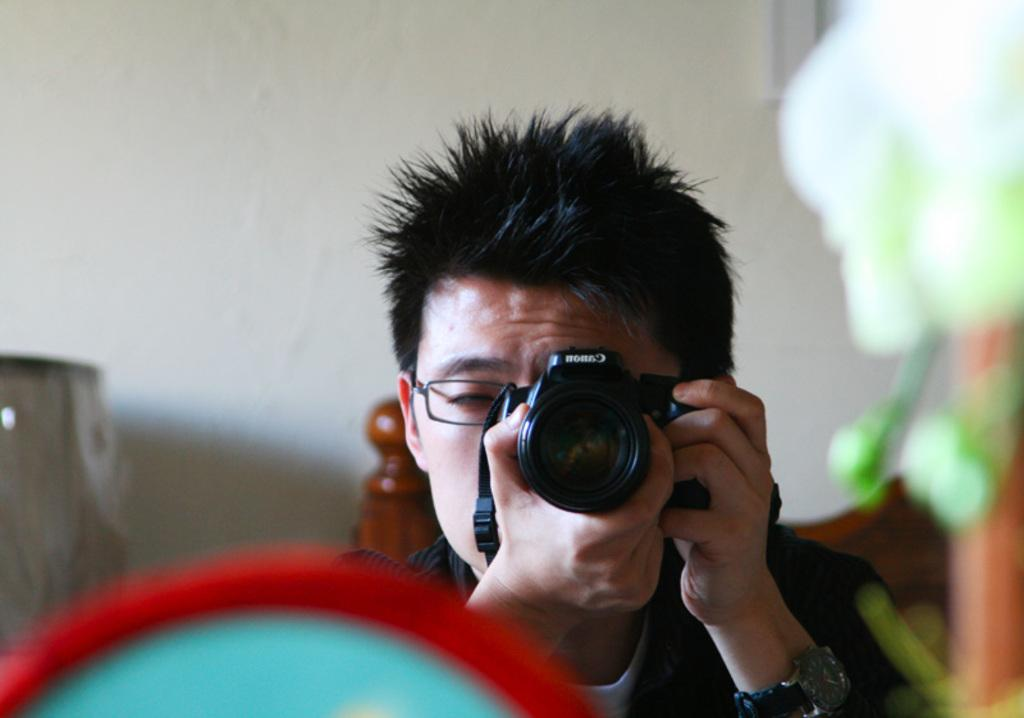Who is the main subject in the image? There is a man in the image. What is the man doing in the image? The man is holding a camera near his eye. What brand of camera is the man using? The camera has "Canon" written on it. What accessories is the man wearing in the image? The man is wearing glasses (specs) and a watch. What color is the man's dress in the image? The man is wearing a black color dress. What channel is the man watching in the image? There is no mention of a channel in the image. The man is holding a camera near his eye, and there is no indication of him watching a channel. 